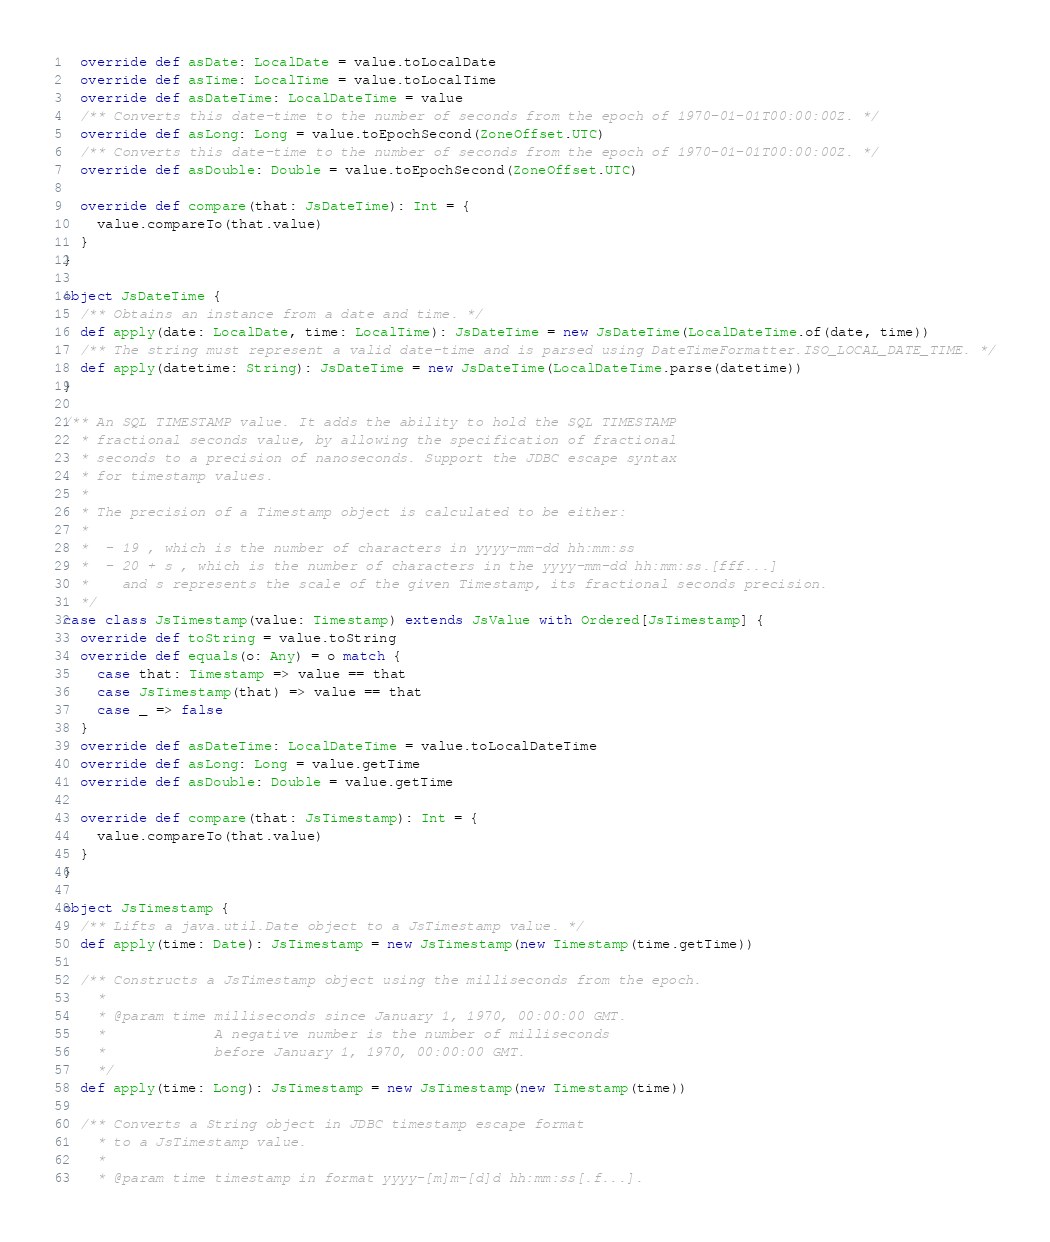Convert code to text. <code><loc_0><loc_0><loc_500><loc_500><_Scala_>  override def asDate: LocalDate = value.toLocalDate
  override def asTime: LocalTime = value.toLocalTime
  override def asDateTime: LocalDateTime = value
  /** Converts this date-time to the number of seconds from the epoch of 1970-01-01T00:00:00Z. */
  override def asLong: Long = value.toEpochSecond(ZoneOffset.UTC)
  /** Converts this date-time to the number of seconds from the epoch of 1970-01-01T00:00:00Z. */
  override def asDouble: Double = value.toEpochSecond(ZoneOffset.UTC)

  override def compare(that: JsDateTime): Int = {
    value.compareTo(that.value)
  }
}

object JsDateTime {
  /** Obtains an instance from a date and time. */
  def apply(date: LocalDate, time: LocalTime): JsDateTime = new JsDateTime(LocalDateTime.of(date, time))
  /** The string must represent a valid date-time and is parsed using DateTimeFormatter.ISO_LOCAL_DATE_TIME. */
  def apply(datetime: String): JsDateTime = new JsDateTime(LocalDateTime.parse(datetime))
}

/** An SQL TIMESTAMP value. It adds the ability to hold the SQL TIMESTAMP
  * fractional seconds value, by allowing the specification of fractional
  * seconds to a precision of nanoseconds. Support the JDBC escape syntax
  * for timestamp values.
  *
  * The precision of a Timestamp object is calculated to be either:
  *
  *  - 19 , which is the number of characters in yyyy-mm-dd hh:mm:ss
  *  - 20 + s , which is the number of characters in the yyyy-mm-dd hh:mm:ss.[fff...]
  *    and s represents the scale of the given Timestamp, its fractional seconds precision.
  */
case class JsTimestamp(value: Timestamp) extends JsValue with Ordered[JsTimestamp] {
  override def toString = value.toString
  override def equals(o: Any) = o match {
    case that: Timestamp => value == that
    case JsTimestamp(that) => value == that
    case _ => false
  }
  override def asDateTime: LocalDateTime = value.toLocalDateTime
  override def asLong: Long = value.getTime
  override def asDouble: Double = value.getTime

  override def compare(that: JsTimestamp): Int = {
    value.compareTo(that.value)
  }
}

object JsTimestamp {
  /** Lifts a java.util.Date object to a JsTimestamp value. */
  def apply(time: Date): JsTimestamp = new JsTimestamp(new Timestamp(time.getTime))

  /** Constructs a JsTimestamp object using the milliseconds from the epoch.
    *
    * @param time milliseconds since January 1, 1970, 00:00:00 GMT.
    *             A negative number is the number of milliseconds
    *             before January 1, 1970, 00:00:00 GMT.
    */
  def apply(time: Long): JsTimestamp = new JsTimestamp(new Timestamp(time))

  /** Converts a String object in JDBC timestamp escape format
    * to a JsTimestamp value.
    *
    * @param time timestamp in format yyyy-[m]m-[d]d hh:mm:ss[.f...].</code> 